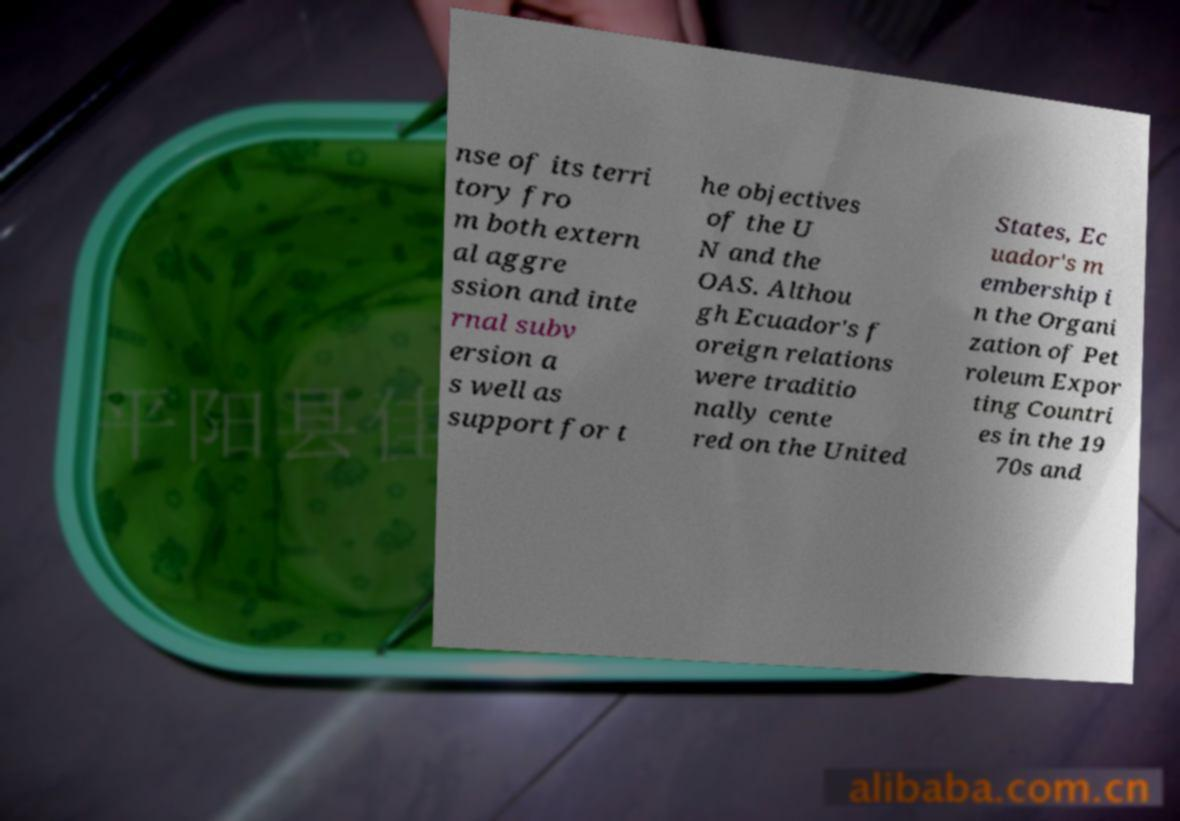Can you accurately transcribe the text from the provided image for me? nse of its terri tory fro m both extern al aggre ssion and inte rnal subv ersion a s well as support for t he objectives of the U N and the OAS. Althou gh Ecuador's f oreign relations were traditio nally cente red on the United States, Ec uador's m embership i n the Organi zation of Pet roleum Expor ting Countri es in the 19 70s and 